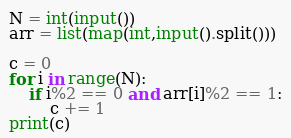Convert code to text. <code><loc_0><loc_0><loc_500><loc_500><_Python_>N = int(input())
arr = list(map(int,input().split()))

c = 0
for i in range(N):
    if i%2 == 0 and arr[i]%2 == 1:
        c += 1
print(c)
</code> 